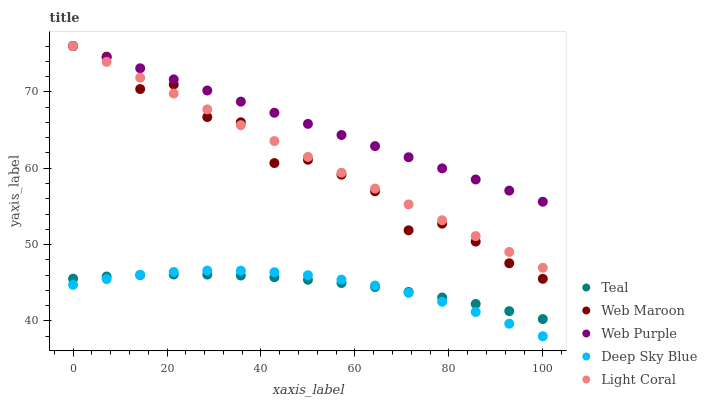Does Deep Sky Blue have the minimum area under the curve?
Answer yes or no. Yes. Does Web Purple have the maximum area under the curve?
Answer yes or no. Yes. Does Web Maroon have the minimum area under the curve?
Answer yes or no. No. Does Web Maroon have the maximum area under the curve?
Answer yes or no. No. Is Light Coral the smoothest?
Answer yes or no. Yes. Is Web Maroon the roughest?
Answer yes or no. Yes. Is Web Purple the smoothest?
Answer yes or no. No. Is Web Purple the roughest?
Answer yes or no. No. Does Deep Sky Blue have the lowest value?
Answer yes or no. Yes. Does Web Maroon have the lowest value?
Answer yes or no. No. Does Web Maroon have the highest value?
Answer yes or no. Yes. Does Deep Sky Blue have the highest value?
Answer yes or no. No. Is Teal less than Light Coral?
Answer yes or no. Yes. Is Web Purple greater than Teal?
Answer yes or no. Yes. Does Web Maroon intersect Web Purple?
Answer yes or no. Yes. Is Web Maroon less than Web Purple?
Answer yes or no. No. Is Web Maroon greater than Web Purple?
Answer yes or no. No. Does Teal intersect Light Coral?
Answer yes or no. No. 